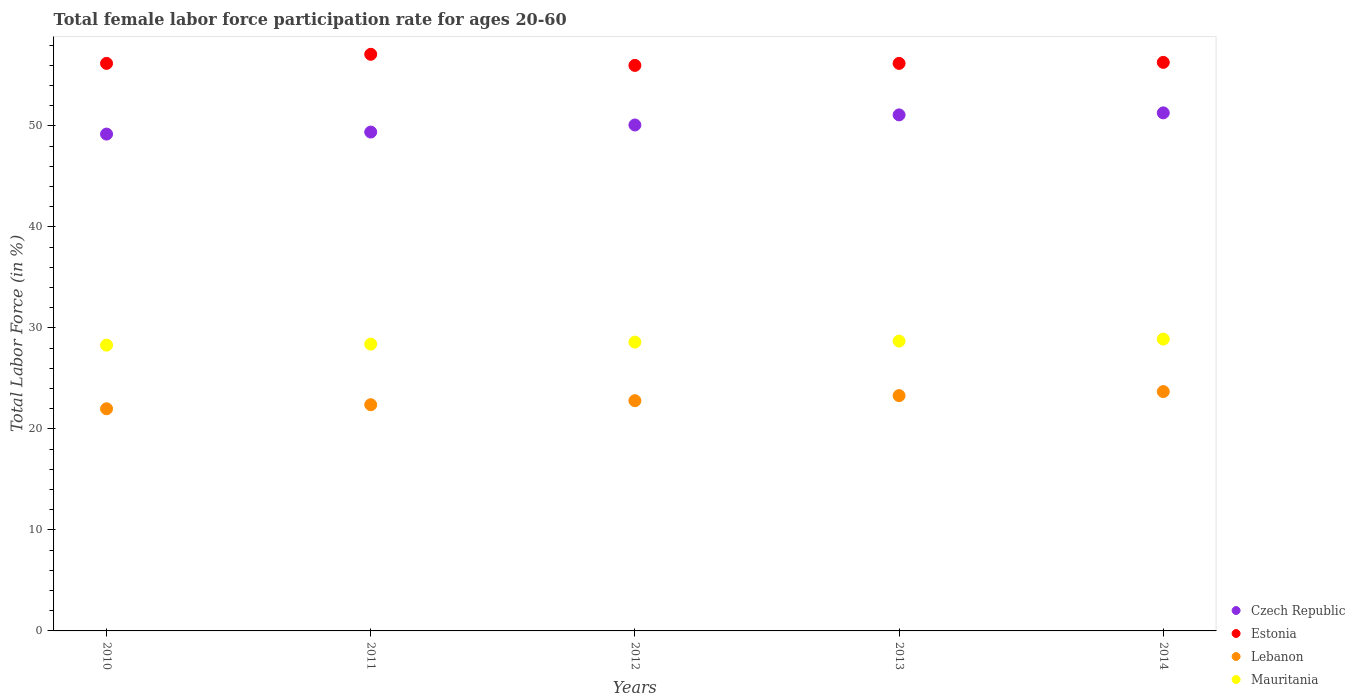Is the number of dotlines equal to the number of legend labels?
Provide a succinct answer. Yes. What is the female labor force participation rate in Estonia in 2010?
Keep it short and to the point. 56.2. Across all years, what is the maximum female labor force participation rate in Czech Republic?
Your answer should be compact. 51.3. Across all years, what is the minimum female labor force participation rate in Czech Republic?
Your response must be concise. 49.2. In which year was the female labor force participation rate in Czech Republic minimum?
Provide a succinct answer. 2010. What is the total female labor force participation rate in Estonia in the graph?
Your answer should be compact. 281.8. What is the difference between the female labor force participation rate in Estonia in 2010 and that in 2014?
Give a very brief answer. -0.1. What is the difference between the female labor force participation rate in Lebanon in 2011 and the female labor force participation rate in Czech Republic in 2010?
Your response must be concise. -26.8. What is the average female labor force participation rate in Czech Republic per year?
Provide a succinct answer. 50.22. In the year 2012, what is the difference between the female labor force participation rate in Czech Republic and female labor force participation rate in Lebanon?
Your answer should be compact. 27.3. What is the ratio of the female labor force participation rate in Czech Republic in 2010 to that in 2011?
Offer a terse response. 1. Is the female labor force participation rate in Mauritania in 2011 less than that in 2013?
Your answer should be very brief. Yes. Is the difference between the female labor force participation rate in Czech Republic in 2012 and 2013 greater than the difference between the female labor force participation rate in Lebanon in 2012 and 2013?
Your answer should be very brief. No. What is the difference between the highest and the second highest female labor force participation rate in Estonia?
Your response must be concise. 0.8. What is the difference between the highest and the lowest female labor force participation rate in Mauritania?
Make the answer very short. 0.6. In how many years, is the female labor force participation rate in Lebanon greater than the average female labor force participation rate in Lebanon taken over all years?
Your answer should be compact. 2. Is the sum of the female labor force participation rate in Lebanon in 2012 and 2014 greater than the maximum female labor force participation rate in Mauritania across all years?
Offer a very short reply. Yes. Is it the case that in every year, the sum of the female labor force participation rate in Czech Republic and female labor force participation rate in Lebanon  is greater than the female labor force participation rate in Estonia?
Offer a terse response. Yes. Does the female labor force participation rate in Estonia monotonically increase over the years?
Provide a short and direct response. No. How many dotlines are there?
Offer a very short reply. 4. What is the difference between two consecutive major ticks on the Y-axis?
Ensure brevity in your answer.  10. Are the values on the major ticks of Y-axis written in scientific E-notation?
Offer a very short reply. No. Where does the legend appear in the graph?
Your response must be concise. Bottom right. How are the legend labels stacked?
Your response must be concise. Vertical. What is the title of the graph?
Ensure brevity in your answer.  Total female labor force participation rate for ages 20-60. What is the label or title of the Y-axis?
Provide a succinct answer. Total Labor Force (in %). What is the Total Labor Force (in %) in Czech Republic in 2010?
Your response must be concise. 49.2. What is the Total Labor Force (in %) in Estonia in 2010?
Ensure brevity in your answer.  56.2. What is the Total Labor Force (in %) in Lebanon in 2010?
Offer a terse response. 22. What is the Total Labor Force (in %) in Mauritania in 2010?
Give a very brief answer. 28.3. What is the Total Labor Force (in %) of Czech Republic in 2011?
Keep it short and to the point. 49.4. What is the Total Labor Force (in %) of Estonia in 2011?
Your answer should be very brief. 57.1. What is the Total Labor Force (in %) of Lebanon in 2011?
Provide a succinct answer. 22.4. What is the Total Labor Force (in %) in Mauritania in 2011?
Keep it short and to the point. 28.4. What is the Total Labor Force (in %) in Czech Republic in 2012?
Ensure brevity in your answer.  50.1. What is the Total Labor Force (in %) of Estonia in 2012?
Give a very brief answer. 56. What is the Total Labor Force (in %) of Lebanon in 2012?
Provide a short and direct response. 22.8. What is the Total Labor Force (in %) in Mauritania in 2012?
Give a very brief answer. 28.6. What is the Total Labor Force (in %) in Czech Republic in 2013?
Offer a very short reply. 51.1. What is the Total Labor Force (in %) of Estonia in 2013?
Provide a short and direct response. 56.2. What is the Total Labor Force (in %) of Lebanon in 2013?
Provide a short and direct response. 23.3. What is the Total Labor Force (in %) of Mauritania in 2013?
Make the answer very short. 28.7. What is the Total Labor Force (in %) in Czech Republic in 2014?
Your response must be concise. 51.3. What is the Total Labor Force (in %) of Estonia in 2014?
Provide a short and direct response. 56.3. What is the Total Labor Force (in %) in Lebanon in 2014?
Provide a succinct answer. 23.7. What is the Total Labor Force (in %) of Mauritania in 2014?
Give a very brief answer. 28.9. Across all years, what is the maximum Total Labor Force (in %) in Czech Republic?
Give a very brief answer. 51.3. Across all years, what is the maximum Total Labor Force (in %) in Estonia?
Your answer should be very brief. 57.1. Across all years, what is the maximum Total Labor Force (in %) of Lebanon?
Your answer should be compact. 23.7. Across all years, what is the maximum Total Labor Force (in %) of Mauritania?
Your response must be concise. 28.9. Across all years, what is the minimum Total Labor Force (in %) of Czech Republic?
Ensure brevity in your answer.  49.2. Across all years, what is the minimum Total Labor Force (in %) in Estonia?
Keep it short and to the point. 56. Across all years, what is the minimum Total Labor Force (in %) of Lebanon?
Give a very brief answer. 22. Across all years, what is the minimum Total Labor Force (in %) in Mauritania?
Your response must be concise. 28.3. What is the total Total Labor Force (in %) in Czech Republic in the graph?
Your answer should be very brief. 251.1. What is the total Total Labor Force (in %) of Estonia in the graph?
Offer a very short reply. 281.8. What is the total Total Labor Force (in %) of Lebanon in the graph?
Offer a very short reply. 114.2. What is the total Total Labor Force (in %) in Mauritania in the graph?
Give a very brief answer. 142.9. What is the difference between the Total Labor Force (in %) of Lebanon in 2010 and that in 2011?
Give a very brief answer. -0.4. What is the difference between the Total Labor Force (in %) of Mauritania in 2010 and that in 2011?
Your answer should be very brief. -0.1. What is the difference between the Total Labor Force (in %) in Czech Republic in 2010 and that in 2012?
Your response must be concise. -0.9. What is the difference between the Total Labor Force (in %) of Estonia in 2010 and that in 2012?
Your answer should be compact. 0.2. What is the difference between the Total Labor Force (in %) in Lebanon in 2010 and that in 2012?
Make the answer very short. -0.8. What is the difference between the Total Labor Force (in %) of Estonia in 2010 and that in 2013?
Make the answer very short. 0. What is the difference between the Total Labor Force (in %) in Czech Republic in 2010 and that in 2014?
Provide a short and direct response. -2.1. What is the difference between the Total Labor Force (in %) of Mauritania in 2010 and that in 2014?
Provide a short and direct response. -0.6. What is the difference between the Total Labor Force (in %) of Estonia in 2011 and that in 2013?
Your response must be concise. 0.9. What is the difference between the Total Labor Force (in %) in Estonia in 2011 and that in 2014?
Ensure brevity in your answer.  0.8. What is the difference between the Total Labor Force (in %) of Mauritania in 2011 and that in 2014?
Provide a short and direct response. -0.5. What is the difference between the Total Labor Force (in %) in Czech Republic in 2012 and that in 2013?
Your answer should be very brief. -1. What is the difference between the Total Labor Force (in %) in Estonia in 2012 and that in 2013?
Keep it short and to the point. -0.2. What is the difference between the Total Labor Force (in %) of Lebanon in 2012 and that in 2013?
Offer a terse response. -0.5. What is the difference between the Total Labor Force (in %) of Mauritania in 2012 and that in 2013?
Make the answer very short. -0.1. What is the difference between the Total Labor Force (in %) of Czech Republic in 2012 and that in 2014?
Your response must be concise. -1.2. What is the difference between the Total Labor Force (in %) of Estonia in 2012 and that in 2014?
Your response must be concise. -0.3. What is the difference between the Total Labor Force (in %) of Estonia in 2013 and that in 2014?
Your response must be concise. -0.1. What is the difference between the Total Labor Force (in %) of Mauritania in 2013 and that in 2014?
Your answer should be very brief. -0.2. What is the difference between the Total Labor Force (in %) in Czech Republic in 2010 and the Total Labor Force (in %) in Estonia in 2011?
Provide a short and direct response. -7.9. What is the difference between the Total Labor Force (in %) of Czech Republic in 2010 and the Total Labor Force (in %) of Lebanon in 2011?
Keep it short and to the point. 26.8. What is the difference between the Total Labor Force (in %) of Czech Republic in 2010 and the Total Labor Force (in %) of Mauritania in 2011?
Provide a succinct answer. 20.8. What is the difference between the Total Labor Force (in %) in Estonia in 2010 and the Total Labor Force (in %) in Lebanon in 2011?
Ensure brevity in your answer.  33.8. What is the difference between the Total Labor Force (in %) of Estonia in 2010 and the Total Labor Force (in %) of Mauritania in 2011?
Your answer should be very brief. 27.8. What is the difference between the Total Labor Force (in %) of Lebanon in 2010 and the Total Labor Force (in %) of Mauritania in 2011?
Your answer should be very brief. -6.4. What is the difference between the Total Labor Force (in %) in Czech Republic in 2010 and the Total Labor Force (in %) in Lebanon in 2012?
Provide a short and direct response. 26.4. What is the difference between the Total Labor Force (in %) of Czech Republic in 2010 and the Total Labor Force (in %) of Mauritania in 2012?
Your answer should be compact. 20.6. What is the difference between the Total Labor Force (in %) in Estonia in 2010 and the Total Labor Force (in %) in Lebanon in 2012?
Offer a terse response. 33.4. What is the difference between the Total Labor Force (in %) in Estonia in 2010 and the Total Labor Force (in %) in Mauritania in 2012?
Your answer should be compact. 27.6. What is the difference between the Total Labor Force (in %) in Lebanon in 2010 and the Total Labor Force (in %) in Mauritania in 2012?
Provide a short and direct response. -6.6. What is the difference between the Total Labor Force (in %) in Czech Republic in 2010 and the Total Labor Force (in %) in Estonia in 2013?
Your response must be concise. -7. What is the difference between the Total Labor Force (in %) in Czech Republic in 2010 and the Total Labor Force (in %) in Lebanon in 2013?
Provide a short and direct response. 25.9. What is the difference between the Total Labor Force (in %) of Estonia in 2010 and the Total Labor Force (in %) of Lebanon in 2013?
Make the answer very short. 32.9. What is the difference between the Total Labor Force (in %) of Estonia in 2010 and the Total Labor Force (in %) of Mauritania in 2013?
Provide a succinct answer. 27.5. What is the difference between the Total Labor Force (in %) of Czech Republic in 2010 and the Total Labor Force (in %) of Mauritania in 2014?
Offer a very short reply. 20.3. What is the difference between the Total Labor Force (in %) in Estonia in 2010 and the Total Labor Force (in %) in Lebanon in 2014?
Offer a terse response. 32.5. What is the difference between the Total Labor Force (in %) in Estonia in 2010 and the Total Labor Force (in %) in Mauritania in 2014?
Make the answer very short. 27.3. What is the difference between the Total Labor Force (in %) in Czech Republic in 2011 and the Total Labor Force (in %) in Estonia in 2012?
Provide a succinct answer. -6.6. What is the difference between the Total Labor Force (in %) of Czech Republic in 2011 and the Total Labor Force (in %) of Lebanon in 2012?
Give a very brief answer. 26.6. What is the difference between the Total Labor Force (in %) of Czech Republic in 2011 and the Total Labor Force (in %) of Mauritania in 2012?
Your answer should be compact. 20.8. What is the difference between the Total Labor Force (in %) in Estonia in 2011 and the Total Labor Force (in %) in Lebanon in 2012?
Make the answer very short. 34.3. What is the difference between the Total Labor Force (in %) of Lebanon in 2011 and the Total Labor Force (in %) of Mauritania in 2012?
Give a very brief answer. -6.2. What is the difference between the Total Labor Force (in %) of Czech Republic in 2011 and the Total Labor Force (in %) of Estonia in 2013?
Provide a short and direct response. -6.8. What is the difference between the Total Labor Force (in %) in Czech Republic in 2011 and the Total Labor Force (in %) in Lebanon in 2013?
Offer a terse response. 26.1. What is the difference between the Total Labor Force (in %) in Czech Republic in 2011 and the Total Labor Force (in %) in Mauritania in 2013?
Provide a short and direct response. 20.7. What is the difference between the Total Labor Force (in %) in Estonia in 2011 and the Total Labor Force (in %) in Lebanon in 2013?
Offer a terse response. 33.8. What is the difference between the Total Labor Force (in %) of Estonia in 2011 and the Total Labor Force (in %) of Mauritania in 2013?
Make the answer very short. 28.4. What is the difference between the Total Labor Force (in %) in Czech Republic in 2011 and the Total Labor Force (in %) in Lebanon in 2014?
Give a very brief answer. 25.7. What is the difference between the Total Labor Force (in %) in Estonia in 2011 and the Total Labor Force (in %) in Lebanon in 2014?
Provide a succinct answer. 33.4. What is the difference between the Total Labor Force (in %) in Estonia in 2011 and the Total Labor Force (in %) in Mauritania in 2014?
Your response must be concise. 28.2. What is the difference between the Total Labor Force (in %) of Lebanon in 2011 and the Total Labor Force (in %) of Mauritania in 2014?
Offer a terse response. -6.5. What is the difference between the Total Labor Force (in %) of Czech Republic in 2012 and the Total Labor Force (in %) of Lebanon in 2013?
Give a very brief answer. 26.8. What is the difference between the Total Labor Force (in %) in Czech Republic in 2012 and the Total Labor Force (in %) in Mauritania in 2013?
Offer a terse response. 21.4. What is the difference between the Total Labor Force (in %) of Estonia in 2012 and the Total Labor Force (in %) of Lebanon in 2013?
Keep it short and to the point. 32.7. What is the difference between the Total Labor Force (in %) in Estonia in 2012 and the Total Labor Force (in %) in Mauritania in 2013?
Give a very brief answer. 27.3. What is the difference between the Total Labor Force (in %) in Lebanon in 2012 and the Total Labor Force (in %) in Mauritania in 2013?
Give a very brief answer. -5.9. What is the difference between the Total Labor Force (in %) in Czech Republic in 2012 and the Total Labor Force (in %) in Estonia in 2014?
Ensure brevity in your answer.  -6.2. What is the difference between the Total Labor Force (in %) of Czech Republic in 2012 and the Total Labor Force (in %) of Lebanon in 2014?
Make the answer very short. 26.4. What is the difference between the Total Labor Force (in %) of Czech Republic in 2012 and the Total Labor Force (in %) of Mauritania in 2014?
Provide a short and direct response. 21.2. What is the difference between the Total Labor Force (in %) in Estonia in 2012 and the Total Labor Force (in %) in Lebanon in 2014?
Ensure brevity in your answer.  32.3. What is the difference between the Total Labor Force (in %) of Estonia in 2012 and the Total Labor Force (in %) of Mauritania in 2014?
Offer a very short reply. 27.1. What is the difference between the Total Labor Force (in %) in Czech Republic in 2013 and the Total Labor Force (in %) in Estonia in 2014?
Provide a short and direct response. -5.2. What is the difference between the Total Labor Force (in %) in Czech Republic in 2013 and the Total Labor Force (in %) in Lebanon in 2014?
Offer a very short reply. 27.4. What is the difference between the Total Labor Force (in %) in Estonia in 2013 and the Total Labor Force (in %) in Lebanon in 2014?
Give a very brief answer. 32.5. What is the difference between the Total Labor Force (in %) of Estonia in 2013 and the Total Labor Force (in %) of Mauritania in 2014?
Give a very brief answer. 27.3. What is the average Total Labor Force (in %) of Czech Republic per year?
Make the answer very short. 50.22. What is the average Total Labor Force (in %) of Estonia per year?
Make the answer very short. 56.36. What is the average Total Labor Force (in %) of Lebanon per year?
Offer a terse response. 22.84. What is the average Total Labor Force (in %) in Mauritania per year?
Your response must be concise. 28.58. In the year 2010, what is the difference between the Total Labor Force (in %) in Czech Republic and Total Labor Force (in %) in Estonia?
Your answer should be very brief. -7. In the year 2010, what is the difference between the Total Labor Force (in %) of Czech Republic and Total Labor Force (in %) of Lebanon?
Give a very brief answer. 27.2. In the year 2010, what is the difference between the Total Labor Force (in %) in Czech Republic and Total Labor Force (in %) in Mauritania?
Your answer should be compact. 20.9. In the year 2010, what is the difference between the Total Labor Force (in %) of Estonia and Total Labor Force (in %) of Lebanon?
Give a very brief answer. 34.2. In the year 2010, what is the difference between the Total Labor Force (in %) in Estonia and Total Labor Force (in %) in Mauritania?
Provide a short and direct response. 27.9. In the year 2011, what is the difference between the Total Labor Force (in %) in Czech Republic and Total Labor Force (in %) in Estonia?
Make the answer very short. -7.7. In the year 2011, what is the difference between the Total Labor Force (in %) in Czech Republic and Total Labor Force (in %) in Mauritania?
Provide a short and direct response. 21. In the year 2011, what is the difference between the Total Labor Force (in %) in Estonia and Total Labor Force (in %) in Lebanon?
Your answer should be compact. 34.7. In the year 2011, what is the difference between the Total Labor Force (in %) in Estonia and Total Labor Force (in %) in Mauritania?
Your answer should be compact. 28.7. In the year 2012, what is the difference between the Total Labor Force (in %) in Czech Republic and Total Labor Force (in %) in Lebanon?
Provide a succinct answer. 27.3. In the year 2012, what is the difference between the Total Labor Force (in %) in Czech Republic and Total Labor Force (in %) in Mauritania?
Offer a very short reply. 21.5. In the year 2012, what is the difference between the Total Labor Force (in %) in Estonia and Total Labor Force (in %) in Lebanon?
Your response must be concise. 33.2. In the year 2012, what is the difference between the Total Labor Force (in %) in Estonia and Total Labor Force (in %) in Mauritania?
Ensure brevity in your answer.  27.4. In the year 2012, what is the difference between the Total Labor Force (in %) of Lebanon and Total Labor Force (in %) of Mauritania?
Offer a terse response. -5.8. In the year 2013, what is the difference between the Total Labor Force (in %) in Czech Republic and Total Labor Force (in %) in Lebanon?
Make the answer very short. 27.8. In the year 2013, what is the difference between the Total Labor Force (in %) of Czech Republic and Total Labor Force (in %) of Mauritania?
Offer a terse response. 22.4. In the year 2013, what is the difference between the Total Labor Force (in %) of Estonia and Total Labor Force (in %) of Lebanon?
Your answer should be compact. 32.9. In the year 2013, what is the difference between the Total Labor Force (in %) in Estonia and Total Labor Force (in %) in Mauritania?
Your answer should be compact. 27.5. In the year 2013, what is the difference between the Total Labor Force (in %) of Lebanon and Total Labor Force (in %) of Mauritania?
Offer a very short reply. -5.4. In the year 2014, what is the difference between the Total Labor Force (in %) of Czech Republic and Total Labor Force (in %) of Estonia?
Make the answer very short. -5. In the year 2014, what is the difference between the Total Labor Force (in %) in Czech Republic and Total Labor Force (in %) in Lebanon?
Your answer should be compact. 27.6. In the year 2014, what is the difference between the Total Labor Force (in %) of Czech Republic and Total Labor Force (in %) of Mauritania?
Provide a short and direct response. 22.4. In the year 2014, what is the difference between the Total Labor Force (in %) in Estonia and Total Labor Force (in %) in Lebanon?
Your response must be concise. 32.6. In the year 2014, what is the difference between the Total Labor Force (in %) in Estonia and Total Labor Force (in %) in Mauritania?
Keep it short and to the point. 27.4. In the year 2014, what is the difference between the Total Labor Force (in %) in Lebanon and Total Labor Force (in %) in Mauritania?
Give a very brief answer. -5.2. What is the ratio of the Total Labor Force (in %) in Estonia in 2010 to that in 2011?
Keep it short and to the point. 0.98. What is the ratio of the Total Labor Force (in %) in Lebanon in 2010 to that in 2011?
Your answer should be very brief. 0.98. What is the ratio of the Total Labor Force (in %) in Mauritania in 2010 to that in 2011?
Keep it short and to the point. 1. What is the ratio of the Total Labor Force (in %) of Estonia in 2010 to that in 2012?
Your response must be concise. 1. What is the ratio of the Total Labor Force (in %) in Lebanon in 2010 to that in 2012?
Ensure brevity in your answer.  0.96. What is the ratio of the Total Labor Force (in %) in Mauritania in 2010 to that in 2012?
Keep it short and to the point. 0.99. What is the ratio of the Total Labor Force (in %) of Czech Republic in 2010 to that in 2013?
Offer a terse response. 0.96. What is the ratio of the Total Labor Force (in %) in Estonia in 2010 to that in 2013?
Give a very brief answer. 1. What is the ratio of the Total Labor Force (in %) of Lebanon in 2010 to that in 2013?
Keep it short and to the point. 0.94. What is the ratio of the Total Labor Force (in %) of Mauritania in 2010 to that in 2013?
Provide a short and direct response. 0.99. What is the ratio of the Total Labor Force (in %) in Czech Republic in 2010 to that in 2014?
Give a very brief answer. 0.96. What is the ratio of the Total Labor Force (in %) in Estonia in 2010 to that in 2014?
Your answer should be compact. 1. What is the ratio of the Total Labor Force (in %) of Lebanon in 2010 to that in 2014?
Provide a succinct answer. 0.93. What is the ratio of the Total Labor Force (in %) of Mauritania in 2010 to that in 2014?
Your answer should be compact. 0.98. What is the ratio of the Total Labor Force (in %) of Czech Republic in 2011 to that in 2012?
Your answer should be compact. 0.99. What is the ratio of the Total Labor Force (in %) in Estonia in 2011 to that in 2012?
Offer a terse response. 1.02. What is the ratio of the Total Labor Force (in %) of Lebanon in 2011 to that in 2012?
Your answer should be very brief. 0.98. What is the ratio of the Total Labor Force (in %) of Czech Republic in 2011 to that in 2013?
Offer a terse response. 0.97. What is the ratio of the Total Labor Force (in %) of Lebanon in 2011 to that in 2013?
Provide a short and direct response. 0.96. What is the ratio of the Total Labor Force (in %) of Estonia in 2011 to that in 2014?
Give a very brief answer. 1.01. What is the ratio of the Total Labor Force (in %) of Lebanon in 2011 to that in 2014?
Make the answer very short. 0.95. What is the ratio of the Total Labor Force (in %) in Mauritania in 2011 to that in 2014?
Provide a succinct answer. 0.98. What is the ratio of the Total Labor Force (in %) of Czech Republic in 2012 to that in 2013?
Ensure brevity in your answer.  0.98. What is the ratio of the Total Labor Force (in %) of Lebanon in 2012 to that in 2013?
Your response must be concise. 0.98. What is the ratio of the Total Labor Force (in %) of Czech Republic in 2012 to that in 2014?
Your answer should be compact. 0.98. What is the ratio of the Total Labor Force (in %) in Czech Republic in 2013 to that in 2014?
Your answer should be very brief. 1. What is the ratio of the Total Labor Force (in %) in Estonia in 2013 to that in 2014?
Give a very brief answer. 1. What is the ratio of the Total Labor Force (in %) of Lebanon in 2013 to that in 2014?
Offer a very short reply. 0.98. What is the ratio of the Total Labor Force (in %) of Mauritania in 2013 to that in 2014?
Your answer should be compact. 0.99. What is the difference between the highest and the second highest Total Labor Force (in %) of Czech Republic?
Make the answer very short. 0.2. What is the difference between the highest and the lowest Total Labor Force (in %) in Estonia?
Your answer should be very brief. 1.1. What is the difference between the highest and the lowest Total Labor Force (in %) in Lebanon?
Provide a short and direct response. 1.7. What is the difference between the highest and the lowest Total Labor Force (in %) of Mauritania?
Your response must be concise. 0.6. 